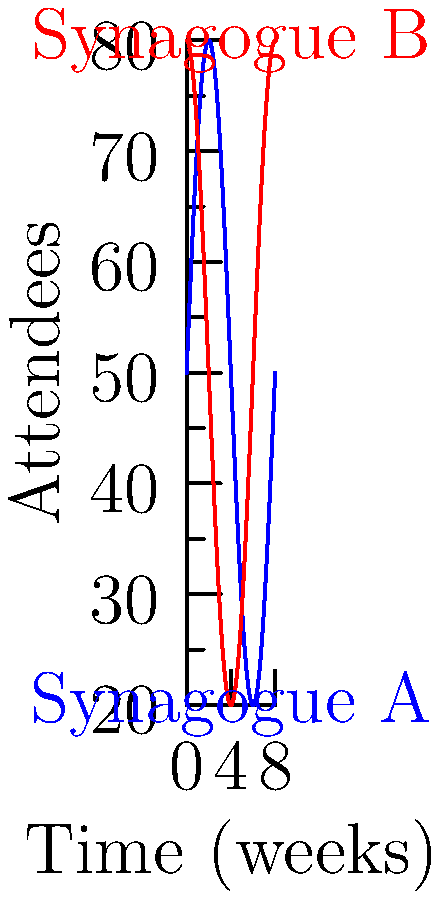The graph shows the number of attendees at two synagogues over an 8-week period. At which week does Synagogue A experience its maximum rate of change in attendance, and what is this rate? To solve this problem, we need to follow these steps:

1) The function for Synagogue A's attendance is of the form:
   $$f(x) = 50 + 30\sin(\frac{\pi x}{4})$$

2) To find the rate of change, we need to differentiate this function:
   $$f'(x) = 30 \cdot \frac{\pi}{4} \cos(\frac{\pi x}{4})$$

3) The maximum rate of change occurs when $\cos(\frac{\pi x}{4})$ is at its maximum, which is 1.

4) This happens when $\frac{\pi x}{4} = 0, 2\pi, 4\pi, ...$

5) Solving for x:
   $x = 0, 8, 16, ...$

6) Within our 8-week period, this occurs at week 0 and week 8.

7) To find the rate at these points, we substitute x=0 into our derivative function:
   $$f'(0) = 30 \cdot \frac{\pi}{4} \cdot 1 = \frac{15\pi}{2} \approx 23.56$$

Therefore, the maximum rate of change occurs at weeks 0 and 8, and the rate is approximately 23.56 attendees per week.
Answer: Weeks 0 and 8; $\frac{15\pi}{2}$ attendees/week 